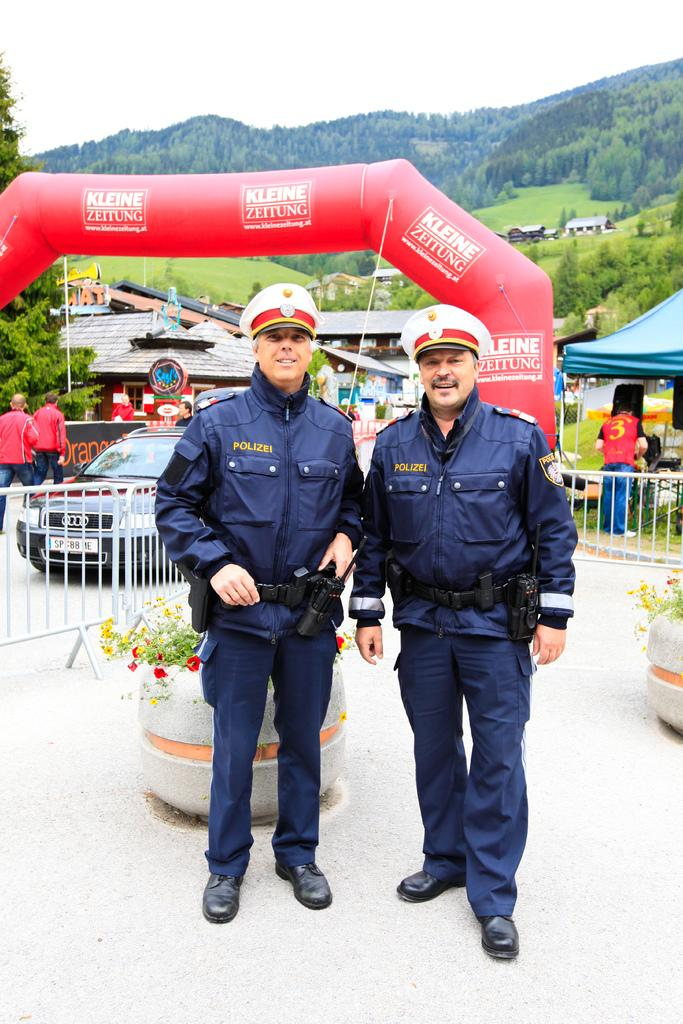How many cops are present in the image? There are 2 cops standing in the image. What is located behind the cops? There is a fencing behind the cops. Can you identify any vehicles in the image? Yes, there is a car visible in the image. Are there any other people besides the cops in the image? Yes, there are other people in the image. What type of temporary shelters can be seen in the image? There are tents in the image. What natural features are visible in the image? There are trees and hills visible in the image. What advice does the grandmother give to the cops in the image? There is no grandmother present in the image, so it is not possible to answer that question. 